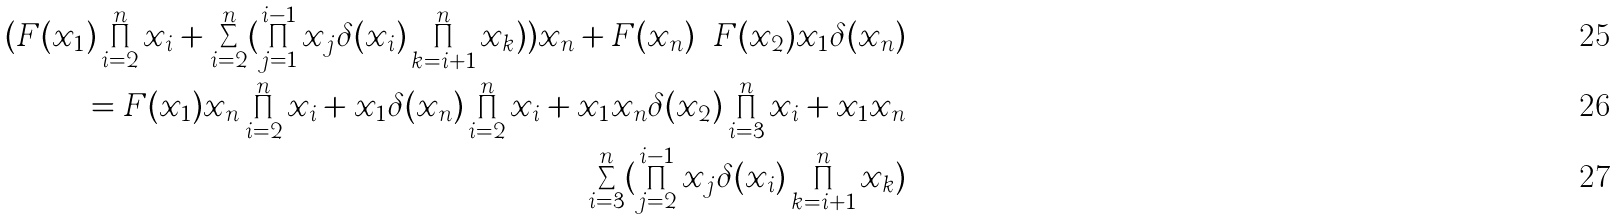<formula> <loc_0><loc_0><loc_500><loc_500>( F ( x _ { 1 } ) \prod _ { i = 2 } ^ { n } x _ { i } + \sum _ { i = 2 } ^ { n } ( \prod _ { j = 1 } ^ { i - 1 } x _ { j } \delta ( x _ { i } ) \prod _ { k = i + 1 } ^ { n } x _ { k } ) ) x _ { n } + F ( x _ { n } ) \cdots F ( x _ { 2 } ) x _ { 1 } \delta ( x _ { n } ) \\ = F ( x _ { 1 } ) x _ { n } \prod _ { i = 2 } ^ { n } x _ { i } + x _ { 1 } \delta ( x _ { n } ) \prod _ { i = 2 } ^ { n } x _ { i } + x _ { 1 } x _ { n } \delta ( x _ { 2 } ) \prod _ { i = 3 } ^ { n } x _ { i } + x _ { 1 } x _ { n } \\ \sum _ { i = 3 } ^ { n } ( \prod _ { j = 2 } ^ { i - 1 } x _ { j } \delta ( x _ { i } ) \prod _ { k = i + 1 } ^ { n } x _ { k } )</formula> 